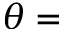Convert formula to latex. <formula><loc_0><loc_0><loc_500><loc_500>\theta =</formula> 